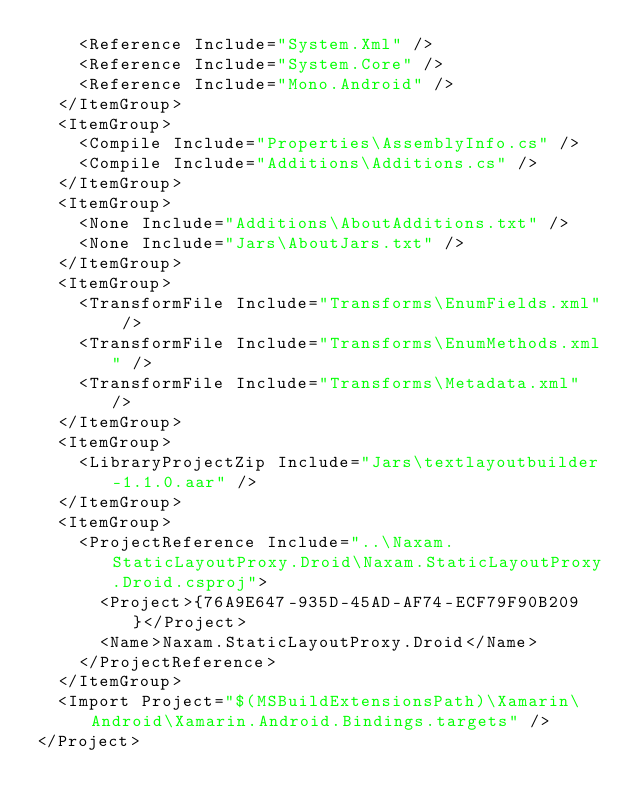<code> <loc_0><loc_0><loc_500><loc_500><_XML_>    <Reference Include="System.Xml" />
    <Reference Include="System.Core" />
    <Reference Include="Mono.Android" />
  </ItemGroup>
  <ItemGroup>
    <Compile Include="Properties\AssemblyInfo.cs" />
    <Compile Include="Additions\Additions.cs" />
  </ItemGroup>
  <ItemGroup>
    <None Include="Additions\AboutAdditions.txt" />
    <None Include="Jars\AboutJars.txt" />
  </ItemGroup>
  <ItemGroup>
    <TransformFile Include="Transforms\EnumFields.xml" />
    <TransformFile Include="Transforms\EnumMethods.xml" />
    <TransformFile Include="Transforms\Metadata.xml" />
  </ItemGroup>
  <ItemGroup>
    <LibraryProjectZip Include="Jars\textlayoutbuilder-1.1.0.aar" />
  </ItemGroup>
  <ItemGroup>
    <ProjectReference Include="..\Naxam.StaticLayoutProxy.Droid\Naxam.StaticLayoutProxy.Droid.csproj">
      <Project>{76A9E647-935D-45AD-AF74-ECF79F90B209}</Project>
      <Name>Naxam.StaticLayoutProxy.Droid</Name>
    </ProjectReference>
  </ItemGroup>
  <Import Project="$(MSBuildExtensionsPath)\Xamarin\Android\Xamarin.Android.Bindings.targets" />
</Project></code> 